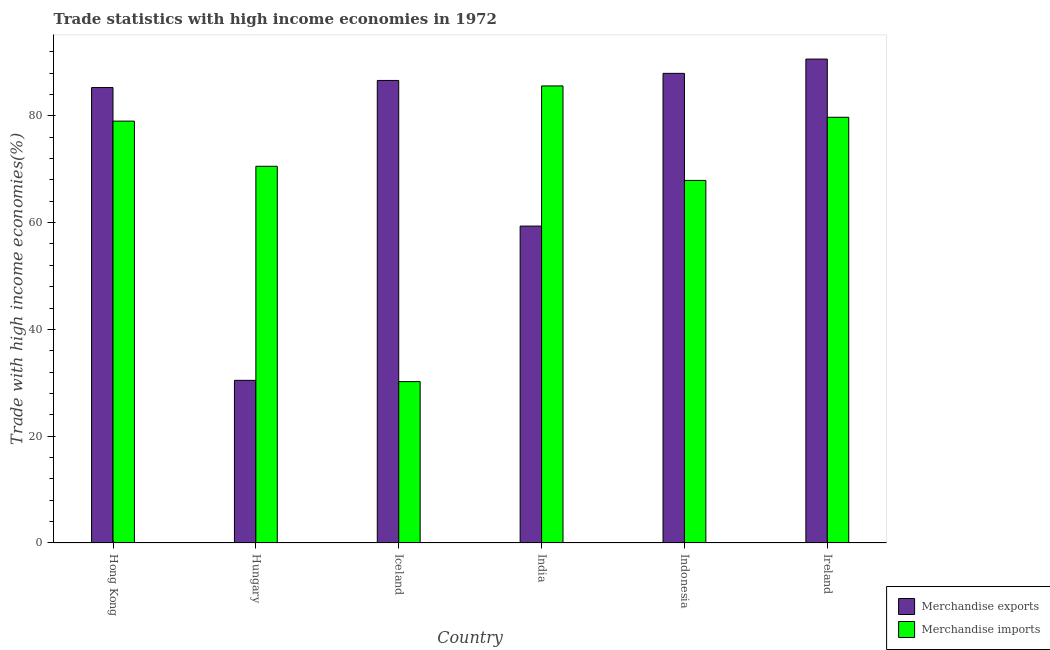Are the number of bars per tick equal to the number of legend labels?
Your answer should be compact. Yes. Are the number of bars on each tick of the X-axis equal?
Make the answer very short. Yes. How many bars are there on the 2nd tick from the left?
Your answer should be compact. 2. How many bars are there on the 2nd tick from the right?
Provide a short and direct response. 2. What is the label of the 5th group of bars from the left?
Offer a very short reply. Indonesia. In how many cases, is the number of bars for a given country not equal to the number of legend labels?
Give a very brief answer. 0. What is the merchandise exports in Iceland?
Your response must be concise. 86.63. Across all countries, what is the maximum merchandise exports?
Provide a succinct answer. 90.63. Across all countries, what is the minimum merchandise exports?
Give a very brief answer. 30.46. In which country was the merchandise exports maximum?
Provide a short and direct response. Ireland. In which country was the merchandise exports minimum?
Ensure brevity in your answer.  Hungary. What is the total merchandise imports in the graph?
Your answer should be compact. 413.02. What is the difference between the merchandise exports in Hungary and that in India?
Provide a succinct answer. -28.89. What is the difference between the merchandise imports in Indonesia and the merchandise exports in Hungary?
Your answer should be compact. 37.44. What is the average merchandise exports per country?
Provide a short and direct response. 73.39. What is the difference between the merchandise exports and merchandise imports in Hong Kong?
Your answer should be very brief. 6.29. What is the ratio of the merchandise imports in Hong Kong to that in Iceland?
Offer a terse response. 2.61. Is the difference between the merchandise exports in India and Ireland greater than the difference between the merchandise imports in India and Ireland?
Give a very brief answer. No. What is the difference between the highest and the second highest merchandise imports?
Give a very brief answer. 5.87. What is the difference between the highest and the lowest merchandise exports?
Provide a succinct answer. 60.17. What does the 2nd bar from the right in Hungary represents?
Ensure brevity in your answer.  Merchandise exports. How many bars are there?
Provide a short and direct response. 12. Are all the bars in the graph horizontal?
Your answer should be very brief. No. How many countries are there in the graph?
Provide a succinct answer. 6. Are the values on the major ticks of Y-axis written in scientific E-notation?
Your answer should be compact. No. Does the graph contain any zero values?
Your response must be concise. No. Does the graph contain grids?
Offer a very short reply. No. How many legend labels are there?
Ensure brevity in your answer.  2. What is the title of the graph?
Offer a terse response. Trade statistics with high income economies in 1972. What is the label or title of the X-axis?
Your response must be concise. Country. What is the label or title of the Y-axis?
Offer a very short reply. Trade with high income economies(%). What is the Trade with high income economies(%) in Merchandise exports in Hong Kong?
Give a very brief answer. 85.3. What is the Trade with high income economies(%) in Merchandise imports in Hong Kong?
Offer a terse response. 79.01. What is the Trade with high income economies(%) in Merchandise exports in Hungary?
Make the answer very short. 30.46. What is the Trade with high income economies(%) in Merchandise imports in Hungary?
Offer a terse response. 70.55. What is the Trade with high income economies(%) in Merchandise exports in Iceland?
Your response must be concise. 86.63. What is the Trade with high income economies(%) of Merchandise imports in Iceland?
Keep it short and to the point. 30.22. What is the Trade with high income economies(%) in Merchandise exports in India?
Offer a terse response. 59.35. What is the Trade with high income economies(%) of Merchandise imports in India?
Ensure brevity in your answer.  85.6. What is the Trade with high income economies(%) of Merchandise exports in Indonesia?
Your answer should be very brief. 87.95. What is the Trade with high income economies(%) of Merchandise imports in Indonesia?
Your answer should be compact. 67.91. What is the Trade with high income economies(%) in Merchandise exports in Ireland?
Offer a very short reply. 90.63. What is the Trade with high income economies(%) in Merchandise imports in Ireland?
Provide a succinct answer. 79.73. Across all countries, what is the maximum Trade with high income economies(%) of Merchandise exports?
Provide a short and direct response. 90.63. Across all countries, what is the maximum Trade with high income economies(%) in Merchandise imports?
Your response must be concise. 85.6. Across all countries, what is the minimum Trade with high income economies(%) in Merchandise exports?
Give a very brief answer. 30.46. Across all countries, what is the minimum Trade with high income economies(%) of Merchandise imports?
Offer a very short reply. 30.22. What is the total Trade with high income economies(%) of Merchandise exports in the graph?
Offer a very short reply. 440.32. What is the total Trade with high income economies(%) of Merchandise imports in the graph?
Provide a short and direct response. 413.02. What is the difference between the Trade with high income economies(%) of Merchandise exports in Hong Kong and that in Hungary?
Your response must be concise. 54.83. What is the difference between the Trade with high income economies(%) in Merchandise imports in Hong Kong and that in Hungary?
Make the answer very short. 8.46. What is the difference between the Trade with high income economies(%) in Merchandise exports in Hong Kong and that in Iceland?
Your answer should be very brief. -1.33. What is the difference between the Trade with high income economies(%) of Merchandise imports in Hong Kong and that in Iceland?
Offer a terse response. 48.79. What is the difference between the Trade with high income economies(%) in Merchandise exports in Hong Kong and that in India?
Provide a succinct answer. 25.94. What is the difference between the Trade with high income economies(%) of Merchandise imports in Hong Kong and that in India?
Provide a short and direct response. -6.59. What is the difference between the Trade with high income economies(%) in Merchandise exports in Hong Kong and that in Indonesia?
Keep it short and to the point. -2.66. What is the difference between the Trade with high income economies(%) in Merchandise imports in Hong Kong and that in Indonesia?
Your response must be concise. 11.1. What is the difference between the Trade with high income economies(%) of Merchandise exports in Hong Kong and that in Ireland?
Provide a succinct answer. -5.34. What is the difference between the Trade with high income economies(%) in Merchandise imports in Hong Kong and that in Ireland?
Offer a terse response. -0.72. What is the difference between the Trade with high income economies(%) of Merchandise exports in Hungary and that in Iceland?
Provide a short and direct response. -56.16. What is the difference between the Trade with high income economies(%) in Merchandise imports in Hungary and that in Iceland?
Make the answer very short. 40.33. What is the difference between the Trade with high income economies(%) in Merchandise exports in Hungary and that in India?
Provide a succinct answer. -28.89. What is the difference between the Trade with high income economies(%) of Merchandise imports in Hungary and that in India?
Make the answer very short. -15.05. What is the difference between the Trade with high income economies(%) of Merchandise exports in Hungary and that in Indonesia?
Provide a short and direct response. -57.49. What is the difference between the Trade with high income economies(%) of Merchandise imports in Hungary and that in Indonesia?
Offer a terse response. 2.64. What is the difference between the Trade with high income economies(%) in Merchandise exports in Hungary and that in Ireland?
Provide a short and direct response. -60.17. What is the difference between the Trade with high income economies(%) of Merchandise imports in Hungary and that in Ireland?
Give a very brief answer. -9.18. What is the difference between the Trade with high income economies(%) in Merchandise exports in Iceland and that in India?
Give a very brief answer. 27.28. What is the difference between the Trade with high income economies(%) of Merchandise imports in Iceland and that in India?
Make the answer very short. -55.38. What is the difference between the Trade with high income economies(%) of Merchandise exports in Iceland and that in Indonesia?
Provide a short and direct response. -1.33. What is the difference between the Trade with high income economies(%) in Merchandise imports in Iceland and that in Indonesia?
Your response must be concise. -37.68. What is the difference between the Trade with high income economies(%) in Merchandise exports in Iceland and that in Ireland?
Your answer should be very brief. -4. What is the difference between the Trade with high income economies(%) of Merchandise imports in Iceland and that in Ireland?
Your answer should be compact. -49.51. What is the difference between the Trade with high income economies(%) in Merchandise exports in India and that in Indonesia?
Provide a succinct answer. -28.6. What is the difference between the Trade with high income economies(%) of Merchandise imports in India and that in Indonesia?
Your answer should be compact. 17.69. What is the difference between the Trade with high income economies(%) in Merchandise exports in India and that in Ireland?
Keep it short and to the point. -31.28. What is the difference between the Trade with high income economies(%) in Merchandise imports in India and that in Ireland?
Provide a short and direct response. 5.87. What is the difference between the Trade with high income economies(%) in Merchandise exports in Indonesia and that in Ireland?
Provide a short and direct response. -2.68. What is the difference between the Trade with high income economies(%) in Merchandise imports in Indonesia and that in Ireland?
Ensure brevity in your answer.  -11.82. What is the difference between the Trade with high income economies(%) in Merchandise exports in Hong Kong and the Trade with high income economies(%) in Merchandise imports in Hungary?
Keep it short and to the point. 14.74. What is the difference between the Trade with high income economies(%) of Merchandise exports in Hong Kong and the Trade with high income economies(%) of Merchandise imports in Iceland?
Keep it short and to the point. 55.07. What is the difference between the Trade with high income economies(%) of Merchandise exports in Hong Kong and the Trade with high income economies(%) of Merchandise imports in India?
Your answer should be compact. -0.3. What is the difference between the Trade with high income economies(%) of Merchandise exports in Hong Kong and the Trade with high income economies(%) of Merchandise imports in Indonesia?
Your answer should be very brief. 17.39. What is the difference between the Trade with high income economies(%) in Merchandise exports in Hong Kong and the Trade with high income economies(%) in Merchandise imports in Ireland?
Ensure brevity in your answer.  5.57. What is the difference between the Trade with high income economies(%) of Merchandise exports in Hungary and the Trade with high income economies(%) of Merchandise imports in Iceland?
Your response must be concise. 0.24. What is the difference between the Trade with high income economies(%) of Merchandise exports in Hungary and the Trade with high income economies(%) of Merchandise imports in India?
Provide a succinct answer. -55.14. What is the difference between the Trade with high income economies(%) in Merchandise exports in Hungary and the Trade with high income economies(%) in Merchandise imports in Indonesia?
Provide a succinct answer. -37.44. What is the difference between the Trade with high income economies(%) of Merchandise exports in Hungary and the Trade with high income economies(%) of Merchandise imports in Ireland?
Provide a succinct answer. -49.27. What is the difference between the Trade with high income economies(%) in Merchandise exports in Iceland and the Trade with high income economies(%) in Merchandise imports in India?
Offer a terse response. 1.03. What is the difference between the Trade with high income economies(%) in Merchandise exports in Iceland and the Trade with high income economies(%) in Merchandise imports in Indonesia?
Your response must be concise. 18.72. What is the difference between the Trade with high income economies(%) of Merchandise exports in Iceland and the Trade with high income economies(%) of Merchandise imports in Ireland?
Make the answer very short. 6.9. What is the difference between the Trade with high income economies(%) in Merchandise exports in India and the Trade with high income economies(%) in Merchandise imports in Indonesia?
Your answer should be very brief. -8.55. What is the difference between the Trade with high income economies(%) of Merchandise exports in India and the Trade with high income economies(%) of Merchandise imports in Ireland?
Your answer should be very brief. -20.38. What is the difference between the Trade with high income economies(%) of Merchandise exports in Indonesia and the Trade with high income economies(%) of Merchandise imports in Ireland?
Provide a succinct answer. 8.22. What is the average Trade with high income economies(%) in Merchandise exports per country?
Your response must be concise. 73.39. What is the average Trade with high income economies(%) of Merchandise imports per country?
Give a very brief answer. 68.84. What is the difference between the Trade with high income economies(%) of Merchandise exports and Trade with high income economies(%) of Merchandise imports in Hong Kong?
Give a very brief answer. 6.29. What is the difference between the Trade with high income economies(%) in Merchandise exports and Trade with high income economies(%) in Merchandise imports in Hungary?
Offer a very short reply. -40.09. What is the difference between the Trade with high income economies(%) in Merchandise exports and Trade with high income economies(%) in Merchandise imports in Iceland?
Give a very brief answer. 56.4. What is the difference between the Trade with high income economies(%) of Merchandise exports and Trade with high income economies(%) of Merchandise imports in India?
Ensure brevity in your answer.  -26.25. What is the difference between the Trade with high income economies(%) in Merchandise exports and Trade with high income economies(%) in Merchandise imports in Indonesia?
Ensure brevity in your answer.  20.05. What is the difference between the Trade with high income economies(%) of Merchandise exports and Trade with high income economies(%) of Merchandise imports in Ireland?
Your answer should be compact. 10.9. What is the ratio of the Trade with high income economies(%) of Merchandise imports in Hong Kong to that in Hungary?
Provide a short and direct response. 1.12. What is the ratio of the Trade with high income economies(%) in Merchandise exports in Hong Kong to that in Iceland?
Provide a short and direct response. 0.98. What is the ratio of the Trade with high income economies(%) in Merchandise imports in Hong Kong to that in Iceland?
Offer a very short reply. 2.61. What is the ratio of the Trade with high income economies(%) of Merchandise exports in Hong Kong to that in India?
Provide a succinct answer. 1.44. What is the ratio of the Trade with high income economies(%) in Merchandise imports in Hong Kong to that in India?
Make the answer very short. 0.92. What is the ratio of the Trade with high income economies(%) of Merchandise exports in Hong Kong to that in Indonesia?
Provide a short and direct response. 0.97. What is the ratio of the Trade with high income economies(%) in Merchandise imports in Hong Kong to that in Indonesia?
Provide a short and direct response. 1.16. What is the ratio of the Trade with high income economies(%) of Merchandise exports in Hong Kong to that in Ireland?
Offer a very short reply. 0.94. What is the ratio of the Trade with high income economies(%) in Merchandise imports in Hong Kong to that in Ireland?
Make the answer very short. 0.99. What is the ratio of the Trade with high income economies(%) of Merchandise exports in Hungary to that in Iceland?
Keep it short and to the point. 0.35. What is the ratio of the Trade with high income economies(%) in Merchandise imports in Hungary to that in Iceland?
Make the answer very short. 2.33. What is the ratio of the Trade with high income economies(%) of Merchandise exports in Hungary to that in India?
Your response must be concise. 0.51. What is the ratio of the Trade with high income economies(%) in Merchandise imports in Hungary to that in India?
Your answer should be very brief. 0.82. What is the ratio of the Trade with high income economies(%) of Merchandise exports in Hungary to that in Indonesia?
Your response must be concise. 0.35. What is the ratio of the Trade with high income economies(%) of Merchandise imports in Hungary to that in Indonesia?
Make the answer very short. 1.04. What is the ratio of the Trade with high income economies(%) in Merchandise exports in Hungary to that in Ireland?
Offer a terse response. 0.34. What is the ratio of the Trade with high income economies(%) in Merchandise imports in Hungary to that in Ireland?
Offer a terse response. 0.88. What is the ratio of the Trade with high income economies(%) of Merchandise exports in Iceland to that in India?
Your answer should be compact. 1.46. What is the ratio of the Trade with high income economies(%) in Merchandise imports in Iceland to that in India?
Your response must be concise. 0.35. What is the ratio of the Trade with high income economies(%) in Merchandise exports in Iceland to that in Indonesia?
Ensure brevity in your answer.  0.98. What is the ratio of the Trade with high income economies(%) in Merchandise imports in Iceland to that in Indonesia?
Your answer should be compact. 0.45. What is the ratio of the Trade with high income economies(%) in Merchandise exports in Iceland to that in Ireland?
Provide a short and direct response. 0.96. What is the ratio of the Trade with high income economies(%) in Merchandise imports in Iceland to that in Ireland?
Give a very brief answer. 0.38. What is the ratio of the Trade with high income economies(%) of Merchandise exports in India to that in Indonesia?
Offer a very short reply. 0.67. What is the ratio of the Trade with high income economies(%) of Merchandise imports in India to that in Indonesia?
Offer a very short reply. 1.26. What is the ratio of the Trade with high income economies(%) of Merchandise exports in India to that in Ireland?
Ensure brevity in your answer.  0.65. What is the ratio of the Trade with high income economies(%) of Merchandise imports in India to that in Ireland?
Keep it short and to the point. 1.07. What is the ratio of the Trade with high income economies(%) of Merchandise exports in Indonesia to that in Ireland?
Provide a short and direct response. 0.97. What is the ratio of the Trade with high income economies(%) of Merchandise imports in Indonesia to that in Ireland?
Provide a succinct answer. 0.85. What is the difference between the highest and the second highest Trade with high income economies(%) of Merchandise exports?
Make the answer very short. 2.68. What is the difference between the highest and the second highest Trade with high income economies(%) in Merchandise imports?
Offer a very short reply. 5.87. What is the difference between the highest and the lowest Trade with high income economies(%) in Merchandise exports?
Provide a short and direct response. 60.17. What is the difference between the highest and the lowest Trade with high income economies(%) in Merchandise imports?
Provide a succinct answer. 55.38. 